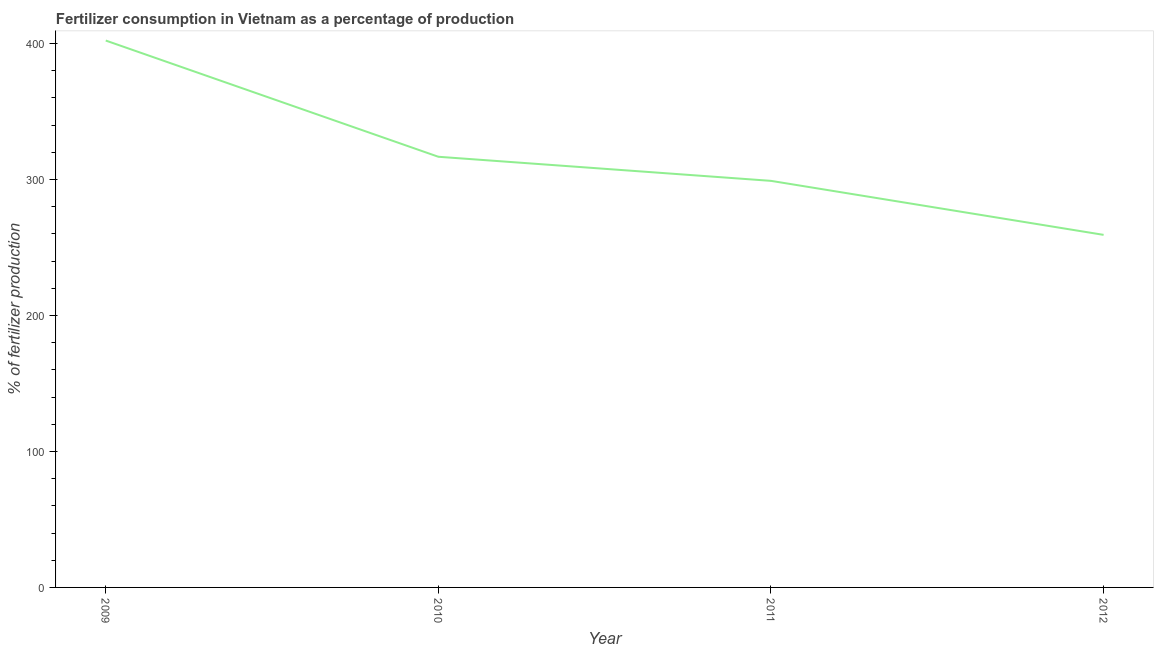What is the amount of fertilizer consumption in 2010?
Your answer should be compact. 316.74. Across all years, what is the maximum amount of fertilizer consumption?
Offer a very short reply. 402.22. Across all years, what is the minimum amount of fertilizer consumption?
Ensure brevity in your answer.  259.29. In which year was the amount of fertilizer consumption maximum?
Your answer should be compact. 2009. In which year was the amount of fertilizer consumption minimum?
Keep it short and to the point. 2012. What is the sum of the amount of fertilizer consumption?
Provide a short and direct response. 1277.27. What is the difference between the amount of fertilizer consumption in 2009 and 2010?
Keep it short and to the point. 85.48. What is the average amount of fertilizer consumption per year?
Make the answer very short. 319.32. What is the median amount of fertilizer consumption?
Your answer should be very brief. 307.88. Do a majority of the years between 2009 and 2010 (inclusive) have amount of fertilizer consumption greater than 120 %?
Your answer should be very brief. Yes. What is the ratio of the amount of fertilizer consumption in 2011 to that in 2012?
Offer a terse response. 1.15. Is the amount of fertilizer consumption in 2010 less than that in 2011?
Offer a terse response. No. Is the difference between the amount of fertilizer consumption in 2010 and 2012 greater than the difference between any two years?
Provide a succinct answer. No. What is the difference between the highest and the second highest amount of fertilizer consumption?
Offer a very short reply. 85.48. What is the difference between the highest and the lowest amount of fertilizer consumption?
Provide a short and direct response. 142.92. What is the difference between two consecutive major ticks on the Y-axis?
Give a very brief answer. 100. Does the graph contain any zero values?
Your answer should be compact. No. Does the graph contain grids?
Your response must be concise. No. What is the title of the graph?
Make the answer very short. Fertilizer consumption in Vietnam as a percentage of production. What is the label or title of the X-axis?
Your response must be concise. Year. What is the label or title of the Y-axis?
Give a very brief answer. % of fertilizer production. What is the % of fertilizer production in 2009?
Your response must be concise. 402.22. What is the % of fertilizer production of 2010?
Give a very brief answer. 316.74. What is the % of fertilizer production of 2011?
Your answer should be very brief. 299.02. What is the % of fertilizer production in 2012?
Give a very brief answer. 259.29. What is the difference between the % of fertilizer production in 2009 and 2010?
Offer a terse response. 85.48. What is the difference between the % of fertilizer production in 2009 and 2011?
Ensure brevity in your answer.  103.2. What is the difference between the % of fertilizer production in 2009 and 2012?
Offer a very short reply. 142.92. What is the difference between the % of fertilizer production in 2010 and 2011?
Make the answer very short. 17.72. What is the difference between the % of fertilizer production in 2010 and 2012?
Keep it short and to the point. 57.44. What is the difference between the % of fertilizer production in 2011 and 2012?
Offer a terse response. 39.72. What is the ratio of the % of fertilizer production in 2009 to that in 2010?
Your answer should be very brief. 1.27. What is the ratio of the % of fertilizer production in 2009 to that in 2011?
Give a very brief answer. 1.34. What is the ratio of the % of fertilizer production in 2009 to that in 2012?
Ensure brevity in your answer.  1.55. What is the ratio of the % of fertilizer production in 2010 to that in 2011?
Make the answer very short. 1.06. What is the ratio of the % of fertilizer production in 2010 to that in 2012?
Provide a succinct answer. 1.22. What is the ratio of the % of fertilizer production in 2011 to that in 2012?
Your answer should be very brief. 1.15. 